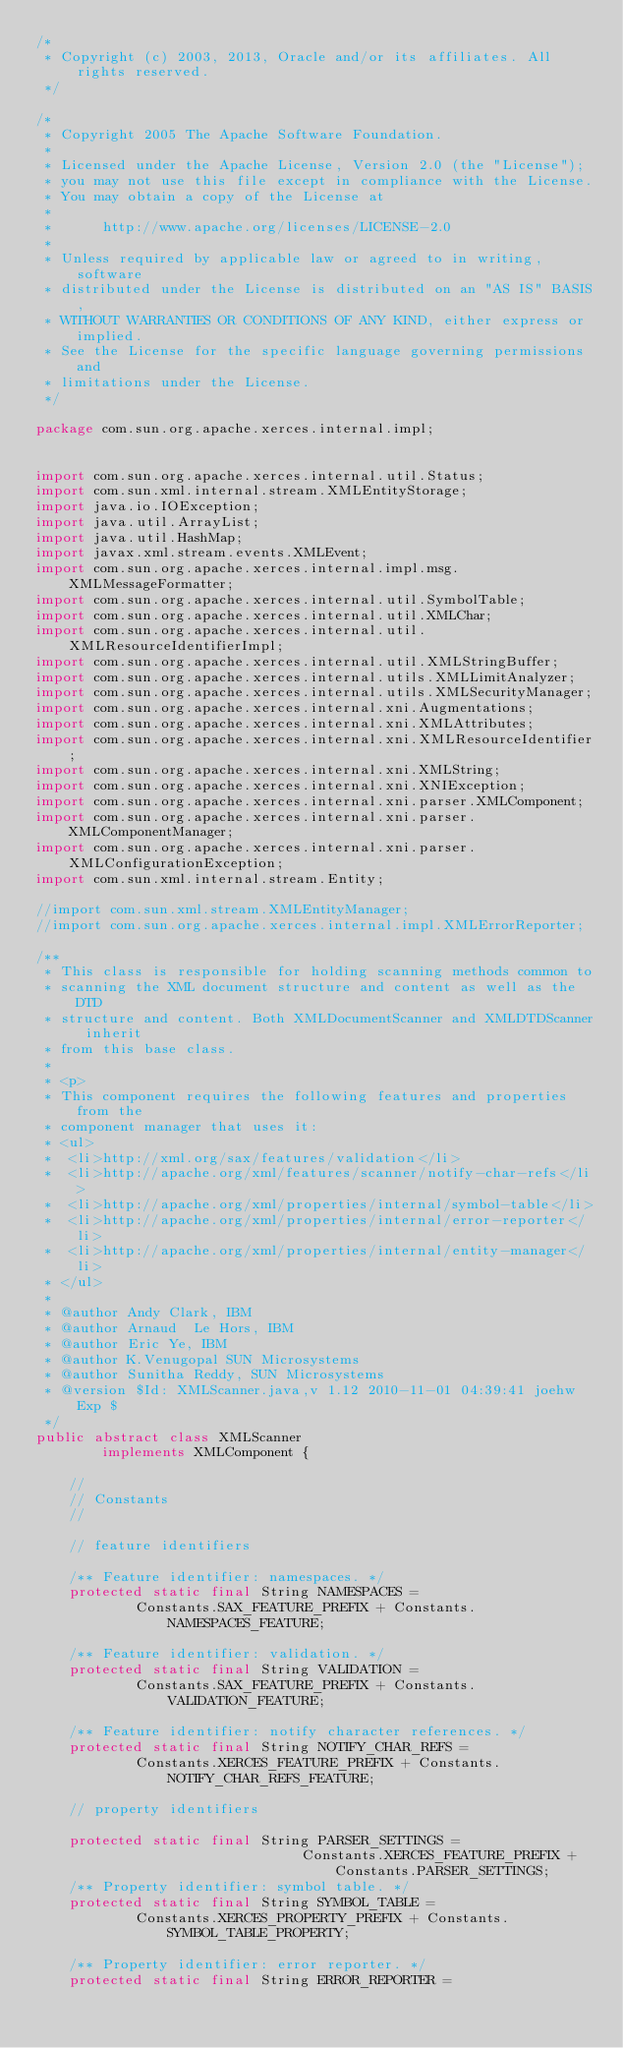<code> <loc_0><loc_0><loc_500><loc_500><_Java_>/*
 * Copyright (c) 2003, 2013, Oracle and/or its affiliates. All rights reserved.
 */

/*
 * Copyright 2005 The Apache Software Foundation.
 *
 * Licensed under the Apache License, Version 2.0 (the "License");
 * you may not use this file except in compliance with the License.
 * You may obtain a copy of the License at
 *
 *      http://www.apache.org/licenses/LICENSE-2.0
 *
 * Unless required by applicable law or agreed to in writing, software
 * distributed under the License is distributed on an "AS IS" BASIS,
 * WITHOUT WARRANTIES OR CONDITIONS OF ANY KIND, either express or implied.
 * See the License for the specific language governing permissions and
 * limitations under the License.
 */

package com.sun.org.apache.xerces.internal.impl;


import com.sun.org.apache.xerces.internal.util.Status;
import com.sun.xml.internal.stream.XMLEntityStorage;
import java.io.IOException;
import java.util.ArrayList;
import java.util.HashMap;
import javax.xml.stream.events.XMLEvent;
import com.sun.org.apache.xerces.internal.impl.msg.XMLMessageFormatter;
import com.sun.org.apache.xerces.internal.util.SymbolTable;
import com.sun.org.apache.xerces.internal.util.XMLChar;
import com.sun.org.apache.xerces.internal.util.XMLResourceIdentifierImpl;
import com.sun.org.apache.xerces.internal.util.XMLStringBuffer;
import com.sun.org.apache.xerces.internal.utils.XMLLimitAnalyzer;
import com.sun.org.apache.xerces.internal.utils.XMLSecurityManager;
import com.sun.org.apache.xerces.internal.xni.Augmentations;
import com.sun.org.apache.xerces.internal.xni.XMLAttributes;
import com.sun.org.apache.xerces.internal.xni.XMLResourceIdentifier;
import com.sun.org.apache.xerces.internal.xni.XMLString;
import com.sun.org.apache.xerces.internal.xni.XNIException;
import com.sun.org.apache.xerces.internal.xni.parser.XMLComponent;
import com.sun.org.apache.xerces.internal.xni.parser.XMLComponentManager;
import com.sun.org.apache.xerces.internal.xni.parser.XMLConfigurationException;
import com.sun.xml.internal.stream.Entity;

//import com.sun.xml.stream.XMLEntityManager;
//import com.sun.org.apache.xerces.internal.impl.XMLErrorReporter;

/**
 * This class is responsible for holding scanning methods common to
 * scanning the XML document structure and content as well as the DTD
 * structure and content. Both XMLDocumentScanner and XMLDTDScanner inherit
 * from this base class.
 *
 * <p>
 * This component requires the following features and properties from the
 * component manager that uses it:
 * <ul>
 *  <li>http://xml.org/sax/features/validation</li>
 *  <li>http://apache.org/xml/features/scanner/notify-char-refs</li>
 *  <li>http://apache.org/xml/properties/internal/symbol-table</li>
 *  <li>http://apache.org/xml/properties/internal/error-reporter</li>
 *  <li>http://apache.org/xml/properties/internal/entity-manager</li>
 * </ul>
 *
 * @author Andy Clark, IBM
 * @author Arnaud  Le Hors, IBM
 * @author Eric Ye, IBM
 * @author K.Venugopal SUN Microsystems
 * @author Sunitha Reddy, SUN Microsystems
 * @version $Id: XMLScanner.java,v 1.12 2010-11-01 04:39:41 joehw Exp $
 */
public abstract class XMLScanner
        implements XMLComponent {

    //
    // Constants
    //

    // feature identifiers

    /** Feature identifier: namespaces. */
    protected static final String NAMESPACES =
            Constants.SAX_FEATURE_PREFIX + Constants.NAMESPACES_FEATURE;

    /** Feature identifier: validation. */
    protected static final String VALIDATION =
            Constants.SAX_FEATURE_PREFIX + Constants.VALIDATION_FEATURE;

    /** Feature identifier: notify character references. */
    protected static final String NOTIFY_CHAR_REFS =
            Constants.XERCES_FEATURE_PREFIX + Constants.NOTIFY_CHAR_REFS_FEATURE;

    // property identifiers

    protected static final String PARSER_SETTINGS =
                                Constants.XERCES_FEATURE_PREFIX + Constants.PARSER_SETTINGS;
    /** Property identifier: symbol table. */
    protected static final String SYMBOL_TABLE =
            Constants.XERCES_PROPERTY_PREFIX + Constants.SYMBOL_TABLE_PROPERTY;

    /** Property identifier: error reporter. */
    protected static final String ERROR_REPORTER =</code> 